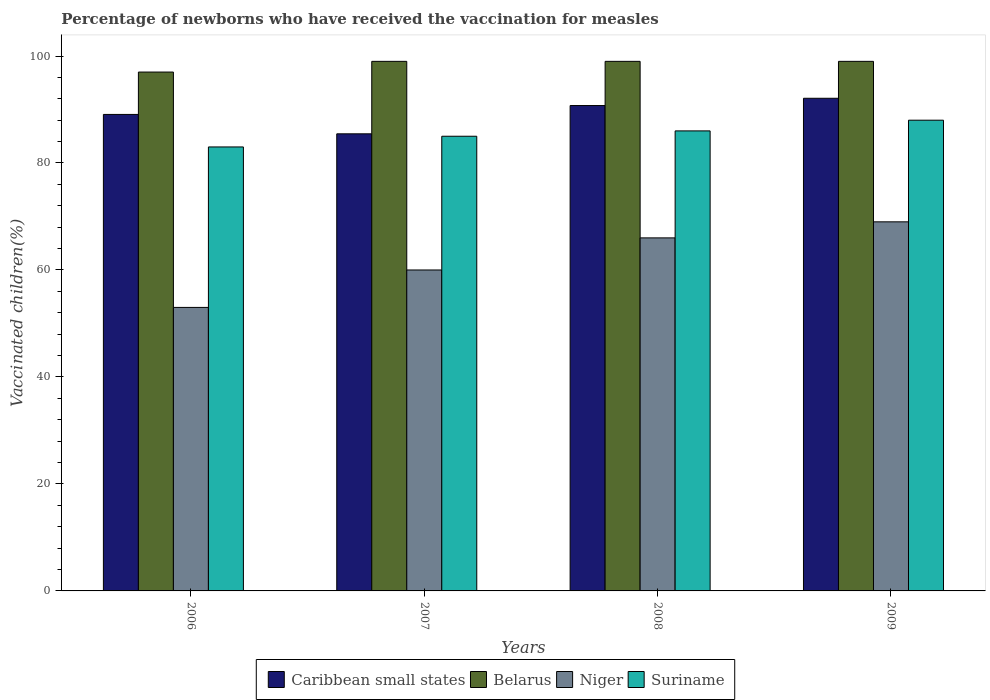How many different coloured bars are there?
Your response must be concise. 4. How many groups of bars are there?
Keep it short and to the point. 4. Are the number of bars per tick equal to the number of legend labels?
Provide a succinct answer. Yes. Are the number of bars on each tick of the X-axis equal?
Your answer should be compact. Yes. How many bars are there on the 1st tick from the left?
Provide a succinct answer. 4. What is the label of the 2nd group of bars from the left?
Offer a very short reply. 2007. In how many cases, is the number of bars for a given year not equal to the number of legend labels?
Make the answer very short. 0. Across all years, what is the maximum percentage of vaccinated children in Caribbean small states?
Your response must be concise. 92.1. Across all years, what is the minimum percentage of vaccinated children in Niger?
Keep it short and to the point. 53. In which year was the percentage of vaccinated children in Niger maximum?
Offer a very short reply. 2009. What is the total percentage of vaccinated children in Niger in the graph?
Offer a terse response. 248. What is the difference between the percentage of vaccinated children in Caribbean small states in 2006 and that in 2009?
Keep it short and to the point. -3.02. What is the difference between the percentage of vaccinated children in Suriname in 2008 and the percentage of vaccinated children in Niger in 2006?
Give a very brief answer. 33. What is the average percentage of vaccinated children in Belarus per year?
Give a very brief answer. 98.5. In the year 2006, what is the difference between the percentage of vaccinated children in Caribbean small states and percentage of vaccinated children in Niger?
Your answer should be very brief. 36.08. What is the ratio of the percentage of vaccinated children in Niger in 2006 to that in 2008?
Ensure brevity in your answer.  0.8. Is the difference between the percentage of vaccinated children in Caribbean small states in 2007 and 2008 greater than the difference between the percentage of vaccinated children in Niger in 2007 and 2008?
Give a very brief answer. Yes. What is the difference between the highest and the second highest percentage of vaccinated children in Belarus?
Your answer should be compact. 0. What does the 1st bar from the left in 2007 represents?
Your response must be concise. Caribbean small states. What does the 3rd bar from the right in 2006 represents?
Ensure brevity in your answer.  Belarus. How many bars are there?
Your answer should be very brief. 16. Are all the bars in the graph horizontal?
Offer a terse response. No. How many years are there in the graph?
Your answer should be very brief. 4. What is the difference between two consecutive major ticks on the Y-axis?
Your response must be concise. 20. Does the graph contain grids?
Provide a succinct answer. No. Where does the legend appear in the graph?
Give a very brief answer. Bottom center. How many legend labels are there?
Offer a terse response. 4. How are the legend labels stacked?
Offer a terse response. Horizontal. What is the title of the graph?
Give a very brief answer. Percentage of newborns who have received the vaccination for measles. What is the label or title of the X-axis?
Make the answer very short. Years. What is the label or title of the Y-axis?
Provide a short and direct response. Vaccinated children(%). What is the Vaccinated children(%) in Caribbean small states in 2006?
Offer a terse response. 89.08. What is the Vaccinated children(%) in Belarus in 2006?
Provide a short and direct response. 97. What is the Vaccinated children(%) of Niger in 2006?
Your answer should be very brief. 53. What is the Vaccinated children(%) in Suriname in 2006?
Keep it short and to the point. 83. What is the Vaccinated children(%) in Caribbean small states in 2007?
Provide a short and direct response. 85.45. What is the Vaccinated children(%) in Belarus in 2007?
Provide a succinct answer. 99. What is the Vaccinated children(%) of Niger in 2007?
Provide a succinct answer. 60. What is the Vaccinated children(%) of Caribbean small states in 2008?
Offer a very short reply. 90.74. What is the Vaccinated children(%) of Belarus in 2008?
Your answer should be very brief. 99. What is the Vaccinated children(%) in Caribbean small states in 2009?
Provide a short and direct response. 92.1. What is the Vaccinated children(%) in Belarus in 2009?
Offer a very short reply. 99. What is the Vaccinated children(%) in Suriname in 2009?
Offer a very short reply. 88. Across all years, what is the maximum Vaccinated children(%) of Caribbean small states?
Your response must be concise. 92.1. Across all years, what is the maximum Vaccinated children(%) in Belarus?
Provide a succinct answer. 99. Across all years, what is the maximum Vaccinated children(%) in Niger?
Your answer should be very brief. 69. Across all years, what is the minimum Vaccinated children(%) of Caribbean small states?
Provide a short and direct response. 85.45. Across all years, what is the minimum Vaccinated children(%) of Belarus?
Keep it short and to the point. 97. Across all years, what is the minimum Vaccinated children(%) of Suriname?
Provide a succinct answer. 83. What is the total Vaccinated children(%) in Caribbean small states in the graph?
Ensure brevity in your answer.  357.37. What is the total Vaccinated children(%) of Belarus in the graph?
Your response must be concise. 394. What is the total Vaccinated children(%) of Niger in the graph?
Ensure brevity in your answer.  248. What is the total Vaccinated children(%) in Suriname in the graph?
Your response must be concise. 342. What is the difference between the Vaccinated children(%) in Caribbean small states in 2006 and that in 2007?
Ensure brevity in your answer.  3.63. What is the difference between the Vaccinated children(%) in Belarus in 2006 and that in 2007?
Your answer should be compact. -2. What is the difference between the Vaccinated children(%) of Niger in 2006 and that in 2007?
Keep it short and to the point. -7. What is the difference between the Vaccinated children(%) in Caribbean small states in 2006 and that in 2008?
Make the answer very short. -1.66. What is the difference between the Vaccinated children(%) of Belarus in 2006 and that in 2008?
Your answer should be very brief. -2. What is the difference between the Vaccinated children(%) of Suriname in 2006 and that in 2008?
Your answer should be very brief. -3. What is the difference between the Vaccinated children(%) of Caribbean small states in 2006 and that in 2009?
Offer a terse response. -3.02. What is the difference between the Vaccinated children(%) of Niger in 2006 and that in 2009?
Provide a succinct answer. -16. What is the difference between the Vaccinated children(%) of Suriname in 2006 and that in 2009?
Provide a short and direct response. -5. What is the difference between the Vaccinated children(%) of Caribbean small states in 2007 and that in 2008?
Your answer should be compact. -5.29. What is the difference between the Vaccinated children(%) in Belarus in 2007 and that in 2008?
Your answer should be very brief. 0. What is the difference between the Vaccinated children(%) of Niger in 2007 and that in 2008?
Your response must be concise. -6. What is the difference between the Vaccinated children(%) of Suriname in 2007 and that in 2008?
Your answer should be compact. -1. What is the difference between the Vaccinated children(%) of Caribbean small states in 2007 and that in 2009?
Your answer should be very brief. -6.64. What is the difference between the Vaccinated children(%) of Caribbean small states in 2008 and that in 2009?
Offer a very short reply. -1.36. What is the difference between the Vaccinated children(%) in Belarus in 2008 and that in 2009?
Give a very brief answer. 0. What is the difference between the Vaccinated children(%) of Niger in 2008 and that in 2009?
Ensure brevity in your answer.  -3. What is the difference between the Vaccinated children(%) in Caribbean small states in 2006 and the Vaccinated children(%) in Belarus in 2007?
Give a very brief answer. -9.92. What is the difference between the Vaccinated children(%) in Caribbean small states in 2006 and the Vaccinated children(%) in Niger in 2007?
Make the answer very short. 29.08. What is the difference between the Vaccinated children(%) in Caribbean small states in 2006 and the Vaccinated children(%) in Suriname in 2007?
Your response must be concise. 4.08. What is the difference between the Vaccinated children(%) in Belarus in 2006 and the Vaccinated children(%) in Suriname in 2007?
Your answer should be very brief. 12. What is the difference between the Vaccinated children(%) of Niger in 2006 and the Vaccinated children(%) of Suriname in 2007?
Your answer should be compact. -32. What is the difference between the Vaccinated children(%) in Caribbean small states in 2006 and the Vaccinated children(%) in Belarus in 2008?
Your response must be concise. -9.92. What is the difference between the Vaccinated children(%) of Caribbean small states in 2006 and the Vaccinated children(%) of Niger in 2008?
Keep it short and to the point. 23.08. What is the difference between the Vaccinated children(%) of Caribbean small states in 2006 and the Vaccinated children(%) of Suriname in 2008?
Give a very brief answer. 3.08. What is the difference between the Vaccinated children(%) of Belarus in 2006 and the Vaccinated children(%) of Suriname in 2008?
Offer a terse response. 11. What is the difference between the Vaccinated children(%) in Niger in 2006 and the Vaccinated children(%) in Suriname in 2008?
Your answer should be compact. -33. What is the difference between the Vaccinated children(%) of Caribbean small states in 2006 and the Vaccinated children(%) of Belarus in 2009?
Provide a short and direct response. -9.92. What is the difference between the Vaccinated children(%) in Caribbean small states in 2006 and the Vaccinated children(%) in Niger in 2009?
Your answer should be very brief. 20.08. What is the difference between the Vaccinated children(%) in Caribbean small states in 2006 and the Vaccinated children(%) in Suriname in 2009?
Ensure brevity in your answer.  1.08. What is the difference between the Vaccinated children(%) in Belarus in 2006 and the Vaccinated children(%) in Suriname in 2009?
Your answer should be very brief. 9. What is the difference between the Vaccinated children(%) of Niger in 2006 and the Vaccinated children(%) of Suriname in 2009?
Offer a very short reply. -35. What is the difference between the Vaccinated children(%) in Caribbean small states in 2007 and the Vaccinated children(%) in Belarus in 2008?
Your response must be concise. -13.55. What is the difference between the Vaccinated children(%) of Caribbean small states in 2007 and the Vaccinated children(%) of Niger in 2008?
Your response must be concise. 19.45. What is the difference between the Vaccinated children(%) of Caribbean small states in 2007 and the Vaccinated children(%) of Suriname in 2008?
Ensure brevity in your answer.  -0.55. What is the difference between the Vaccinated children(%) of Caribbean small states in 2007 and the Vaccinated children(%) of Belarus in 2009?
Offer a very short reply. -13.55. What is the difference between the Vaccinated children(%) of Caribbean small states in 2007 and the Vaccinated children(%) of Niger in 2009?
Your answer should be very brief. 16.45. What is the difference between the Vaccinated children(%) in Caribbean small states in 2007 and the Vaccinated children(%) in Suriname in 2009?
Your response must be concise. -2.55. What is the difference between the Vaccinated children(%) of Belarus in 2007 and the Vaccinated children(%) of Niger in 2009?
Keep it short and to the point. 30. What is the difference between the Vaccinated children(%) in Niger in 2007 and the Vaccinated children(%) in Suriname in 2009?
Provide a short and direct response. -28. What is the difference between the Vaccinated children(%) of Caribbean small states in 2008 and the Vaccinated children(%) of Belarus in 2009?
Your response must be concise. -8.26. What is the difference between the Vaccinated children(%) of Caribbean small states in 2008 and the Vaccinated children(%) of Niger in 2009?
Give a very brief answer. 21.74. What is the difference between the Vaccinated children(%) of Caribbean small states in 2008 and the Vaccinated children(%) of Suriname in 2009?
Your answer should be very brief. 2.74. What is the difference between the Vaccinated children(%) of Belarus in 2008 and the Vaccinated children(%) of Suriname in 2009?
Offer a very short reply. 11. What is the average Vaccinated children(%) in Caribbean small states per year?
Ensure brevity in your answer.  89.34. What is the average Vaccinated children(%) in Belarus per year?
Keep it short and to the point. 98.5. What is the average Vaccinated children(%) in Niger per year?
Offer a terse response. 62. What is the average Vaccinated children(%) in Suriname per year?
Provide a short and direct response. 85.5. In the year 2006, what is the difference between the Vaccinated children(%) in Caribbean small states and Vaccinated children(%) in Belarus?
Your answer should be compact. -7.92. In the year 2006, what is the difference between the Vaccinated children(%) in Caribbean small states and Vaccinated children(%) in Niger?
Provide a succinct answer. 36.08. In the year 2006, what is the difference between the Vaccinated children(%) of Caribbean small states and Vaccinated children(%) of Suriname?
Ensure brevity in your answer.  6.08. In the year 2006, what is the difference between the Vaccinated children(%) in Belarus and Vaccinated children(%) in Suriname?
Your response must be concise. 14. In the year 2007, what is the difference between the Vaccinated children(%) of Caribbean small states and Vaccinated children(%) of Belarus?
Provide a short and direct response. -13.55. In the year 2007, what is the difference between the Vaccinated children(%) in Caribbean small states and Vaccinated children(%) in Niger?
Provide a short and direct response. 25.45. In the year 2007, what is the difference between the Vaccinated children(%) in Caribbean small states and Vaccinated children(%) in Suriname?
Give a very brief answer. 0.45. In the year 2007, what is the difference between the Vaccinated children(%) of Niger and Vaccinated children(%) of Suriname?
Provide a short and direct response. -25. In the year 2008, what is the difference between the Vaccinated children(%) in Caribbean small states and Vaccinated children(%) in Belarus?
Offer a very short reply. -8.26. In the year 2008, what is the difference between the Vaccinated children(%) of Caribbean small states and Vaccinated children(%) of Niger?
Make the answer very short. 24.74. In the year 2008, what is the difference between the Vaccinated children(%) in Caribbean small states and Vaccinated children(%) in Suriname?
Make the answer very short. 4.74. In the year 2009, what is the difference between the Vaccinated children(%) in Caribbean small states and Vaccinated children(%) in Belarus?
Ensure brevity in your answer.  -6.9. In the year 2009, what is the difference between the Vaccinated children(%) of Caribbean small states and Vaccinated children(%) of Niger?
Your response must be concise. 23.1. In the year 2009, what is the difference between the Vaccinated children(%) in Caribbean small states and Vaccinated children(%) in Suriname?
Ensure brevity in your answer.  4.1. In the year 2009, what is the difference between the Vaccinated children(%) in Belarus and Vaccinated children(%) in Niger?
Keep it short and to the point. 30. What is the ratio of the Vaccinated children(%) of Caribbean small states in 2006 to that in 2007?
Your answer should be very brief. 1.04. What is the ratio of the Vaccinated children(%) in Belarus in 2006 to that in 2007?
Give a very brief answer. 0.98. What is the ratio of the Vaccinated children(%) of Niger in 2006 to that in 2007?
Your answer should be very brief. 0.88. What is the ratio of the Vaccinated children(%) of Suriname in 2006 to that in 2007?
Make the answer very short. 0.98. What is the ratio of the Vaccinated children(%) in Caribbean small states in 2006 to that in 2008?
Your answer should be compact. 0.98. What is the ratio of the Vaccinated children(%) in Belarus in 2006 to that in 2008?
Make the answer very short. 0.98. What is the ratio of the Vaccinated children(%) in Niger in 2006 to that in 2008?
Your answer should be compact. 0.8. What is the ratio of the Vaccinated children(%) of Suriname in 2006 to that in 2008?
Offer a very short reply. 0.97. What is the ratio of the Vaccinated children(%) of Caribbean small states in 2006 to that in 2009?
Give a very brief answer. 0.97. What is the ratio of the Vaccinated children(%) of Belarus in 2006 to that in 2009?
Give a very brief answer. 0.98. What is the ratio of the Vaccinated children(%) of Niger in 2006 to that in 2009?
Offer a very short reply. 0.77. What is the ratio of the Vaccinated children(%) of Suriname in 2006 to that in 2009?
Your answer should be very brief. 0.94. What is the ratio of the Vaccinated children(%) of Caribbean small states in 2007 to that in 2008?
Ensure brevity in your answer.  0.94. What is the ratio of the Vaccinated children(%) of Niger in 2007 to that in 2008?
Your answer should be very brief. 0.91. What is the ratio of the Vaccinated children(%) of Suriname in 2007 to that in 2008?
Offer a very short reply. 0.99. What is the ratio of the Vaccinated children(%) in Caribbean small states in 2007 to that in 2009?
Your answer should be very brief. 0.93. What is the ratio of the Vaccinated children(%) in Niger in 2007 to that in 2009?
Your response must be concise. 0.87. What is the ratio of the Vaccinated children(%) in Suriname in 2007 to that in 2009?
Your answer should be very brief. 0.97. What is the ratio of the Vaccinated children(%) of Caribbean small states in 2008 to that in 2009?
Your answer should be very brief. 0.99. What is the ratio of the Vaccinated children(%) in Niger in 2008 to that in 2009?
Provide a succinct answer. 0.96. What is the ratio of the Vaccinated children(%) of Suriname in 2008 to that in 2009?
Your answer should be compact. 0.98. What is the difference between the highest and the second highest Vaccinated children(%) in Caribbean small states?
Ensure brevity in your answer.  1.36. What is the difference between the highest and the lowest Vaccinated children(%) in Caribbean small states?
Give a very brief answer. 6.64. What is the difference between the highest and the lowest Vaccinated children(%) in Niger?
Keep it short and to the point. 16. What is the difference between the highest and the lowest Vaccinated children(%) of Suriname?
Make the answer very short. 5. 